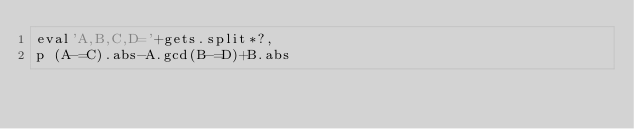<code> <loc_0><loc_0><loc_500><loc_500><_Ruby_>eval'A,B,C,D='+gets.split*?,
p (A-=C).abs-A.gcd(B-=D)+B.abs</code> 